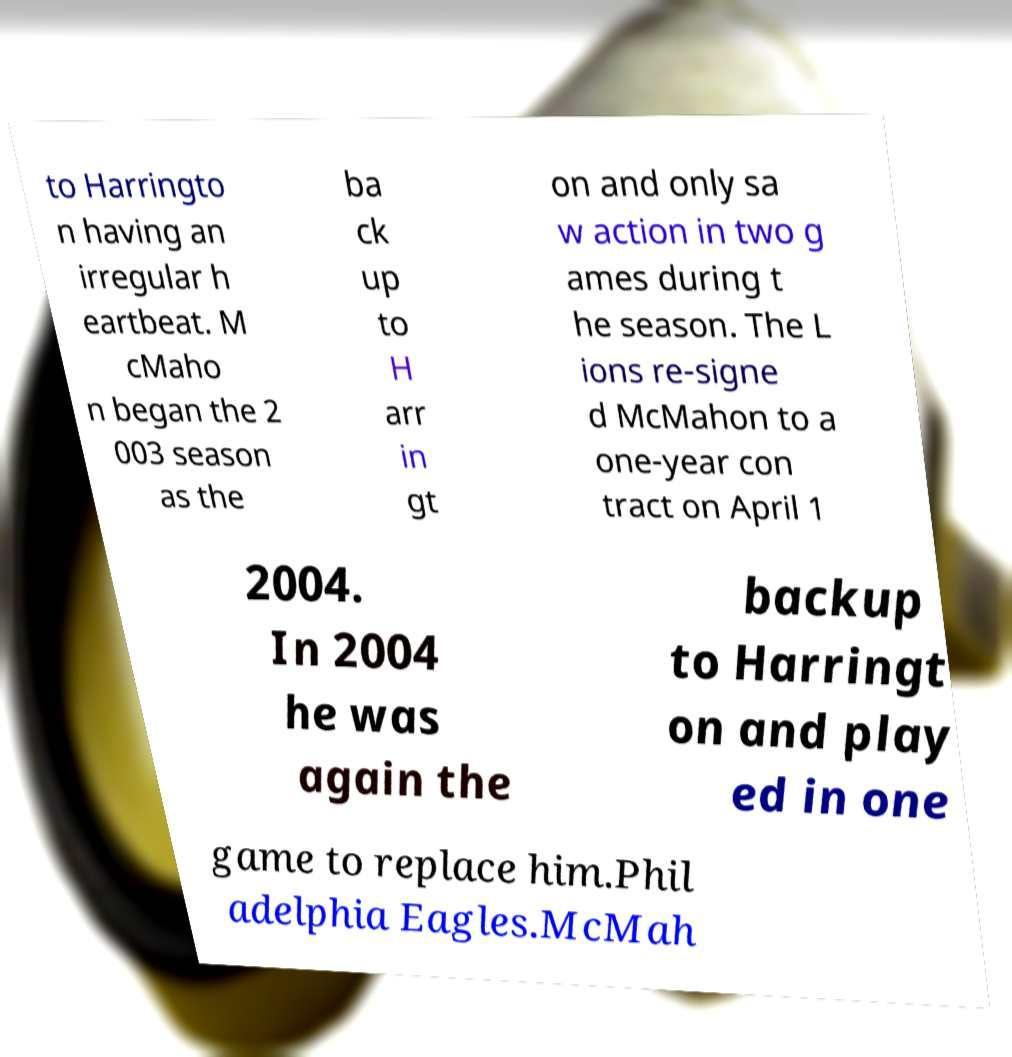Please read and relay the text visible in this image. What does it say? to Harringto n having an irregular h eartbeat. M cMaho n began the 2 003 season as the ba ck up to H arr in gt on and only sa w action in two g ames during t he season. The L ions re-signe d McMahon to a one-year con tract on April 1 2004. In 2004 he was again the backup to Harringt on and play ed in one game to replace him.Phil adelphia Eagles.McMah 